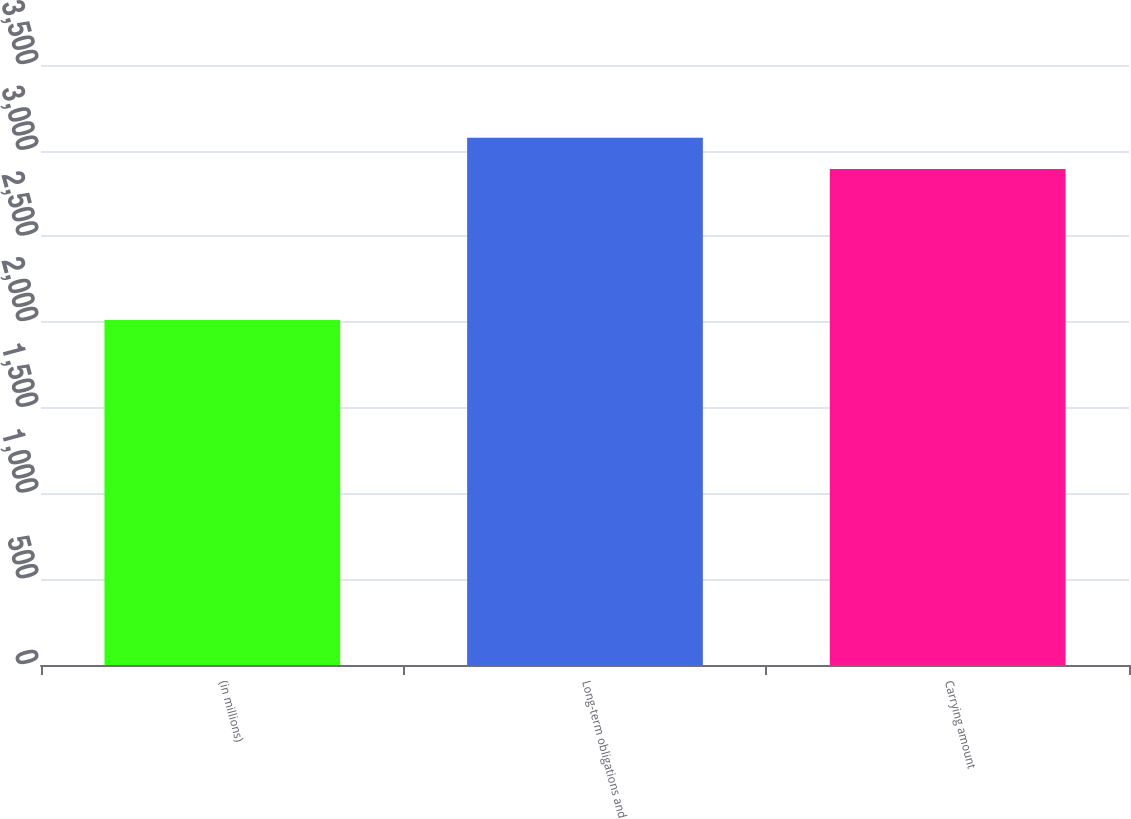Convert chart to OTSL. <chart><loc_0><loc_0><loc_500><loc_500><bar_chart><fcel>(in millions)<fcel>Long-term obligations and<fcel>Carrying amount<nl><fcel>2012<fcel>3075<fcel>2894<nl></chart> 